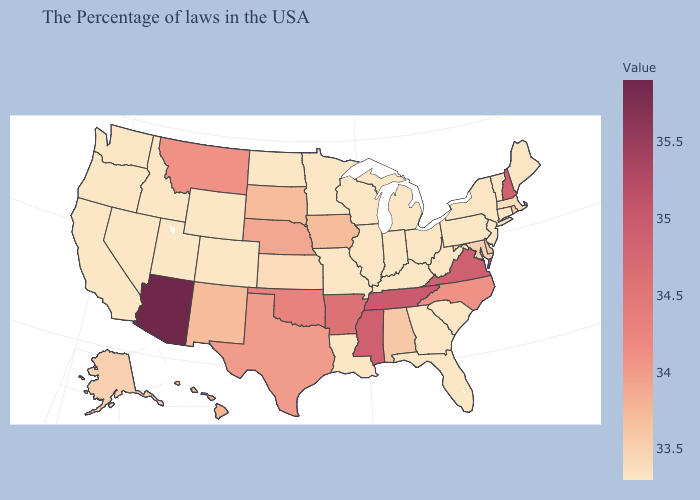Is the legend a continuous bar?
Concise answer only. Yes. Does Massachusetts have the highest value in the Northeast?
Write a very short answer. No. Which states have the lowest value in the Northeast?
Be succinct. Maine, Vermont, Connecticut, New York, New Jersey, Pennsylvania. Among the states that border South Dakota , which have the highest value?
Write a very short answer. Montana. Among the states that border South Carolina , which have the lowest value?
Give a very brief answer. Georgia. Which states have the lowest value in the USA?
Be succinct. Maine, Vermont, Connecticut, New York, New Jersey, Pennsylvania, South Carolina, West Virginia, Ohio, Florida, Georgia, Michigan, Kentucky, Indiana, Wisconsin, Illinois, Louisiana, Missouri, Minnesota, North Dakota, Wyoming, Colorado, Utah, Idaho, Nevada, California, Washington, Oregon. Among the states that border Kentucky , which have the lowest value?
Answer briefly. West Virginia, Ohio, Indiana, Illinois, Missouri. Among the states that border Iowa , which have the highest value?
Give a very brief answer. Nebraska. 